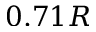<formula> <loc_0><loc_0><loc_500><loc_500>0 . 7 1 R</formula> 